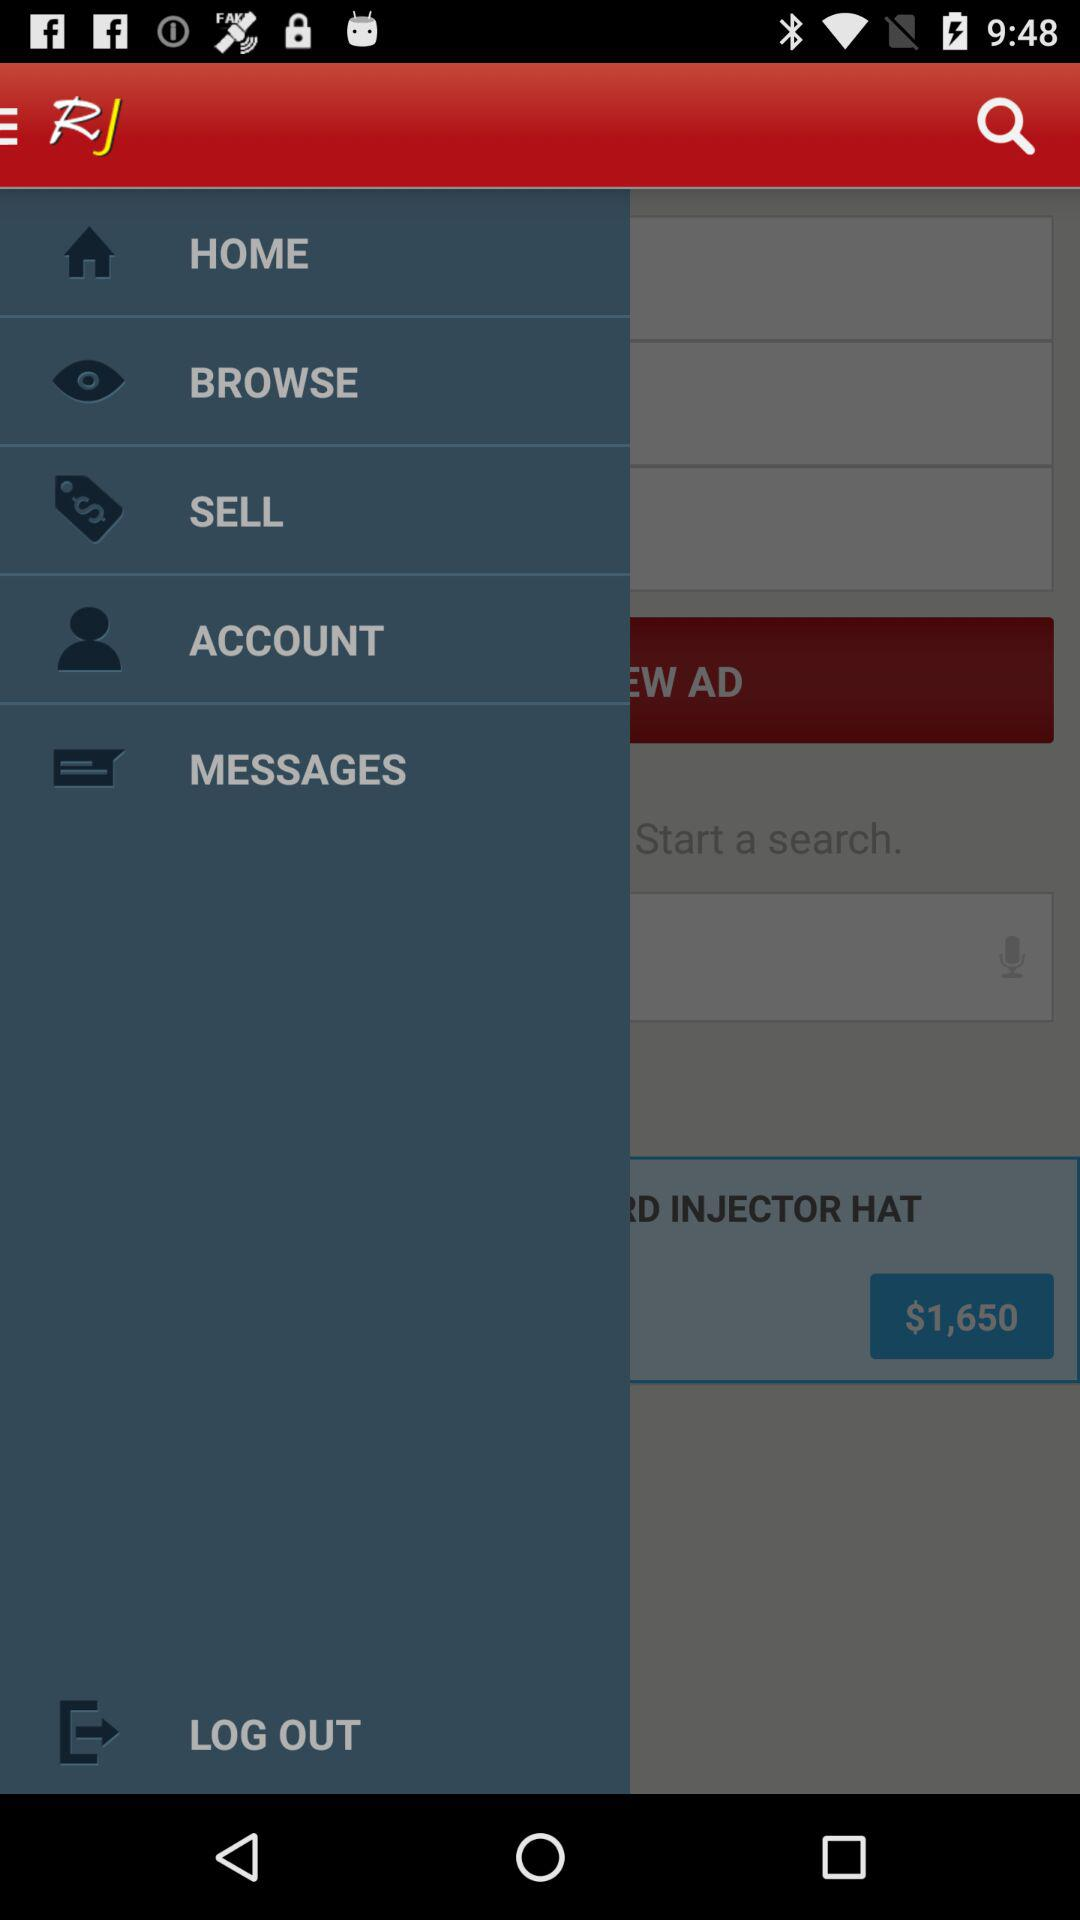How much is the item RD INJECTOR HAT?
Answer the question using a single word or phrase. $1,650 